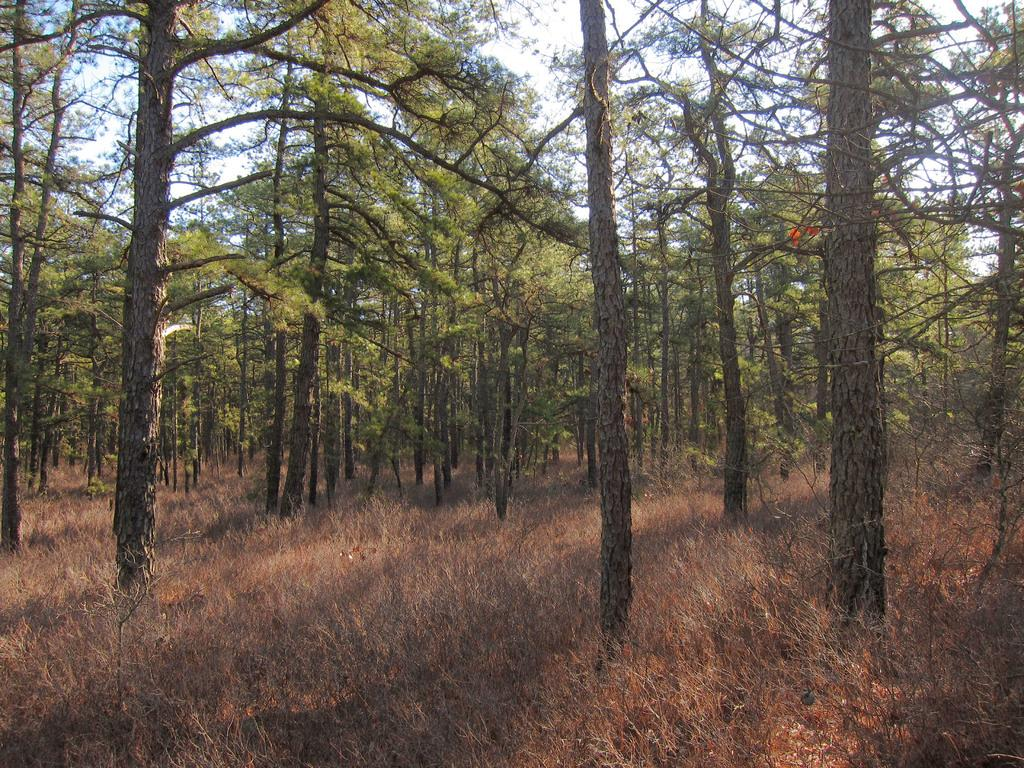What type of vegetation can be seen in the image? There are trees and dried plants in the image. What part of the natural environment is visible in the image? The sky is visible in the image. What direction are the trees leaning in the image? The trees are not leaning in any specific direction in the image; they are standing upright. What design can be seen on the dried plants in the image? There is no design on the dried plants in the image; they are simply dried and not decorated or patterned. 